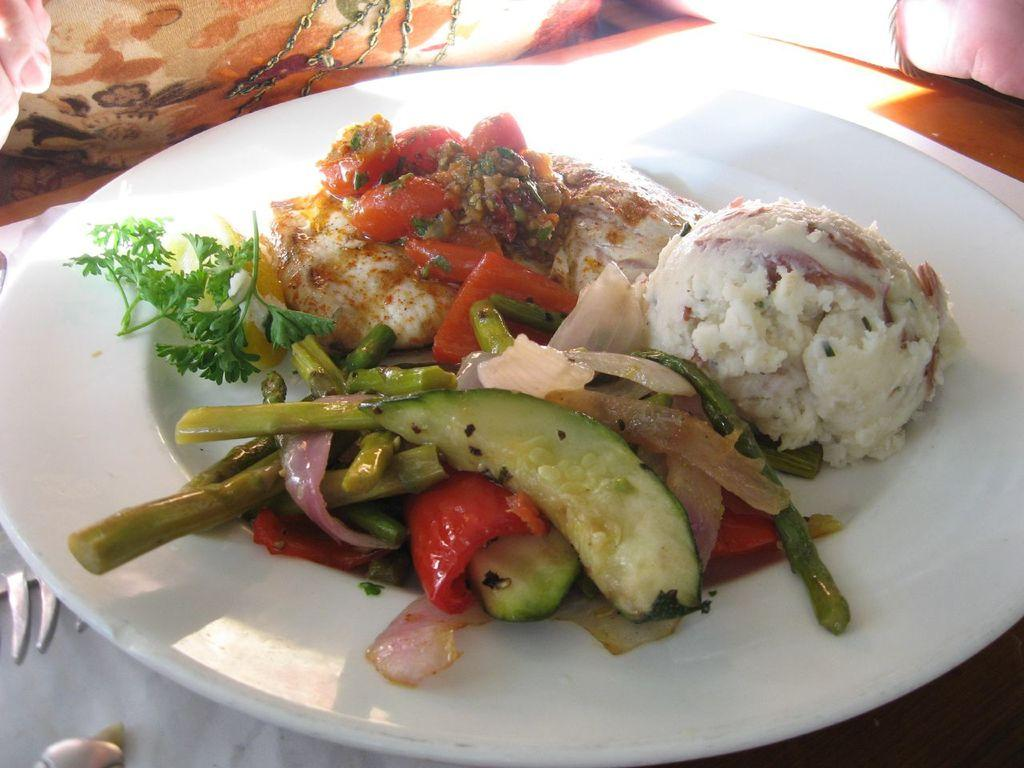What is the main subject in the center of the image? There are food items in a plate in the center of the image. What is located at the bottom of the image? There is a table at the bottom of the image. What is the price of the basketball on the table in the image? There is no basketball present in the image, so it is not possible to determine its price. 